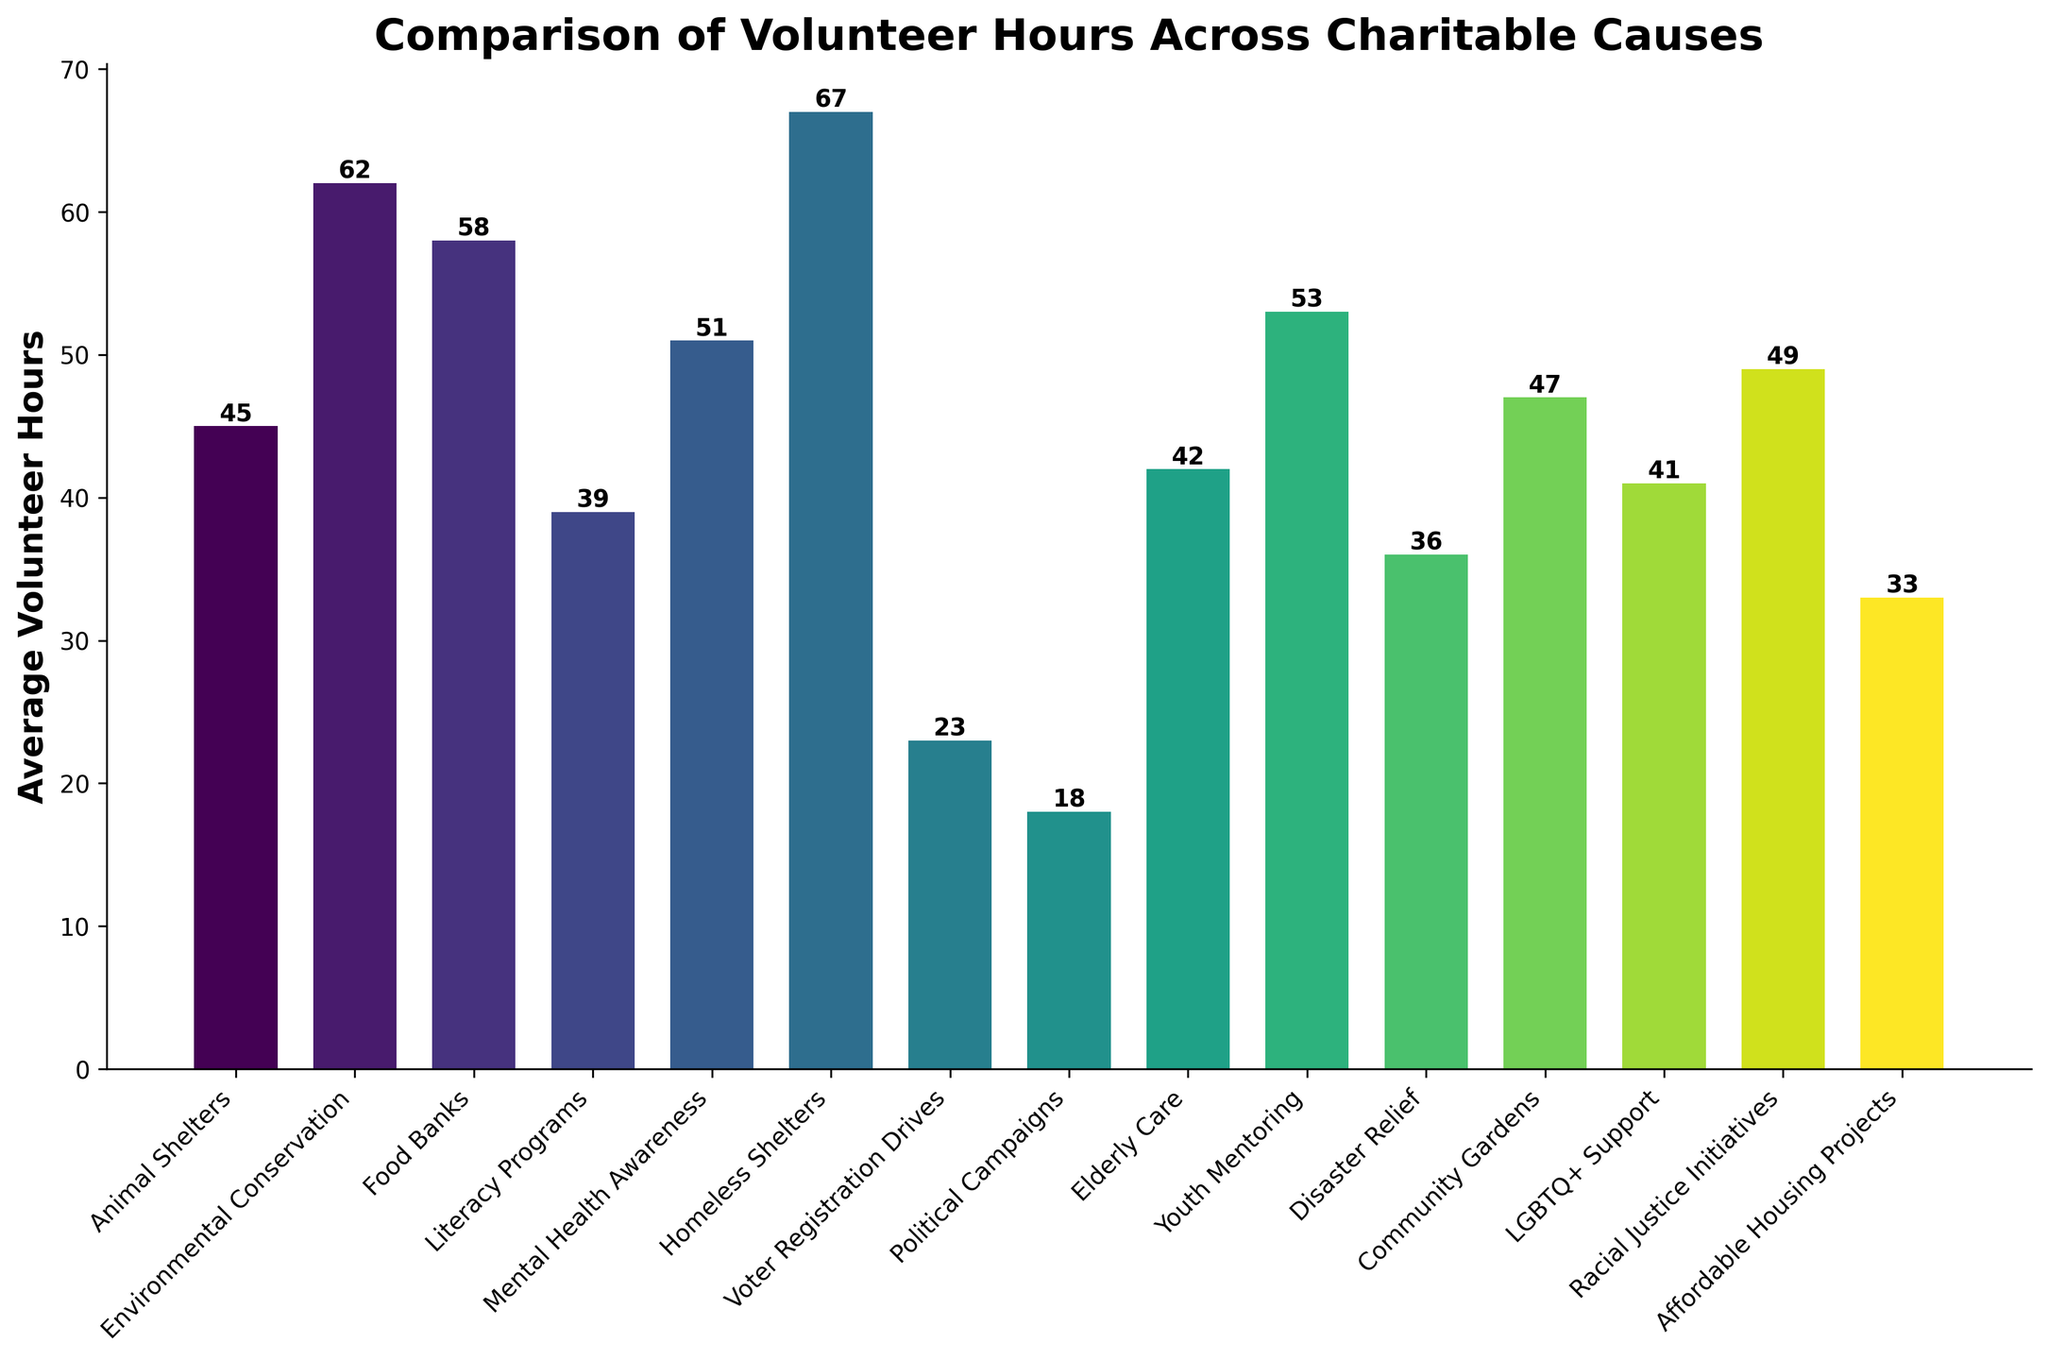Which cause has the highest average volunteer hours? By inspecting the height of the bars in the chart, Homeless Shelters has the tallest bar, indicating it has the highest average volunteer hours.
Answer: Homeless Shelters Which two causes have the lowest average volunteer hours? By looking at the shortest bars, Political Campaigns and Voter Registration Drives have the shortest bars.
Answer: Political Campaigns and Voter Registration Drives What is the difference in average volunteer hours between the highest and lowest causes? The highest average volunteer hours are for Homeless Shelters at 67 hours, and the lowest are for Political Campaigns at 18 hours. Subtracting 18 from 67 gives the difference. 67 - 18 = 49.
Answer: 49 Which cause has more volunteer hours: Animal Shelters or Youth Mentoring? Comparing the height of the bars for Animal Shelters and Youth Mentoring, Youth Mentoring's bar is taller.
Answer: Youth Mentoring What is the average of the top three causes in terms of volunteer hours? The top three causes are Homeless Shelters (67), Environmental Conservation (62), and Food Banks (58). Adding these up (67 + 62 + 58) and dividing by 3 will give the average. (67 + 62 + 58) / 3 = 62.33.
Answer: 62.33 How many causes have average volunteer hours greater than 50? By visually inspecting the bars that extend beyond the 50-hour mark, there are five causes: Homeless Shelters, Environmental Conservation, Food Banks, Youth Mentoring, and Mental Health Awareness.
Answer: 5 Which causes have an average volunteer hours between 40 and 50? Bars whose heights fall between the 40 and 50-hour marks correspond to Community Gardens, Mental Health Awareness, Elderly Care, LGBTQ+ Support, and Racial Justice Initiatives.
Answer: Community Gardens, Mental Health Awareness, Elderly Care, LGBTQ+ Support, and Racial Justice Initiatives What is the sum of average volunteer hours for Literacy Programs, Elderly Care, and LGBTQ+ Support? By adding the values: Literacy Programs (39), Elderly Care (42), LGBTQ+ Support (41). 39 + 42 + 41 = 122.
Answer: 122 Which has more volunteer hours: Disaster Relief or Affordable Housing Projects? By comparing the heights of the bars for Disaster Relief and Affordable Housing Projects, Disaster Relief has a taller bar.
Answer: Disaster Relief What is the median value of average volunteer hours across all causes? Arranging the data in ascending order: 18, 23, 33, 36, 39, 41, 42, 45, 47, 49, 51, 53, 58, 62, 67. The median value is in the middle, 45 (8th position out of 15 causes).
Answer: 45 